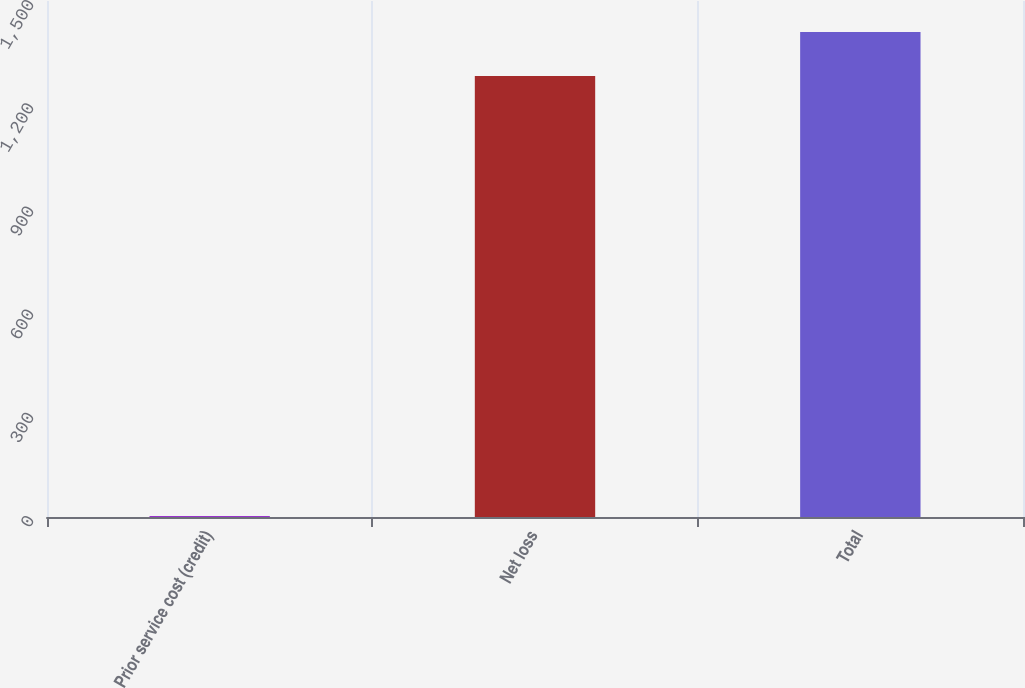Convert chart to OTSL. <chart><loc_0><loc_0><loc_500><loc_500><bar_chart><fcel>Prior service cost (credit)<fcel>Net loss<fcel>Total<nl><fcel>3<fcel>1282<fcel>1410.2<nl></chart> 